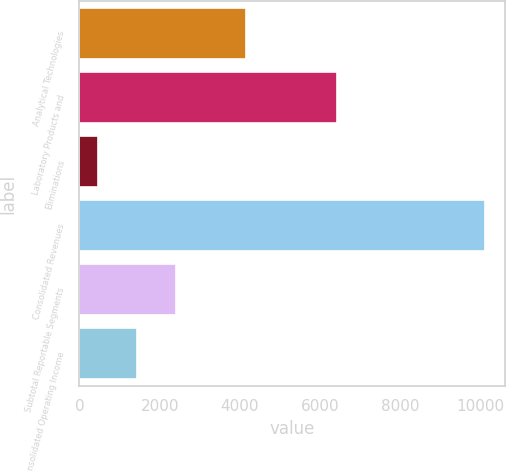Convert chart. <chart><loc_0><loc_0><loc_500><loc_500><bar_chart><fcel>Analytical Technologies<fcel>Laboratory Products and<fcel>Eliminations<fcel>Consolidated Revenues<fcel>Subtotal Reportable Segments<fcel>Consolidated Operating Income<nl><fcel>4153.9<fcel>6426.6<fcel>470.8<fcel>10109.7<fcel>2398.58<fcel>1434.69<nl></chart> 